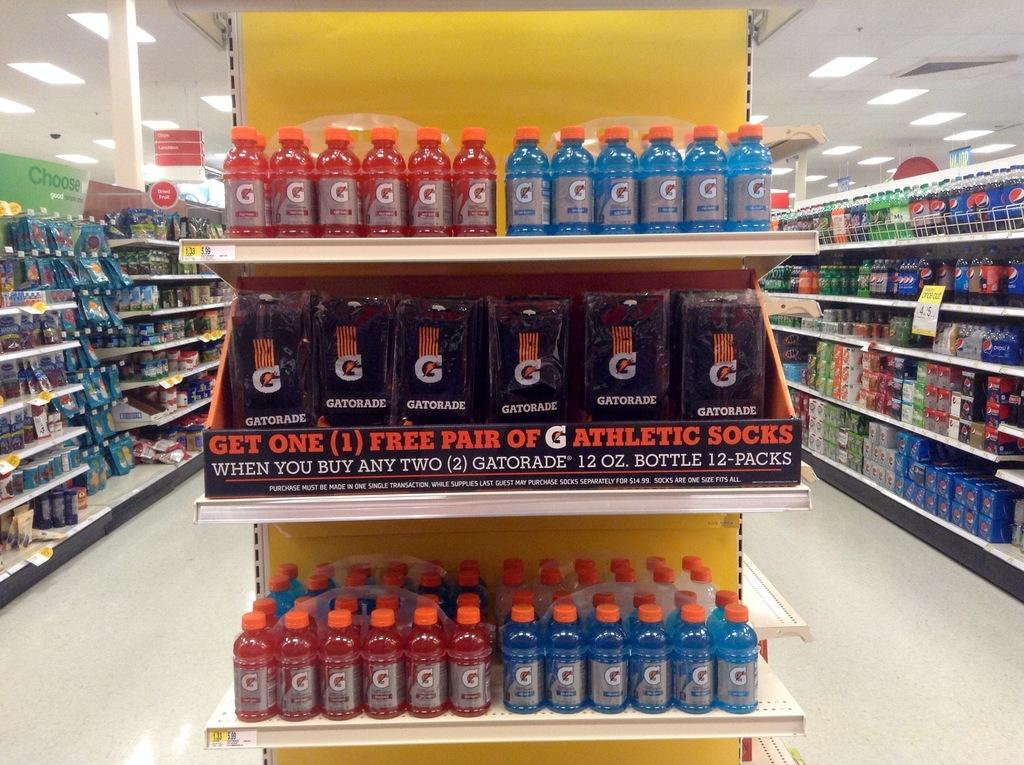<image>
Relay a brief, clear account of the picture shown. A Gatorade display advertises a free socks with a purchase. 